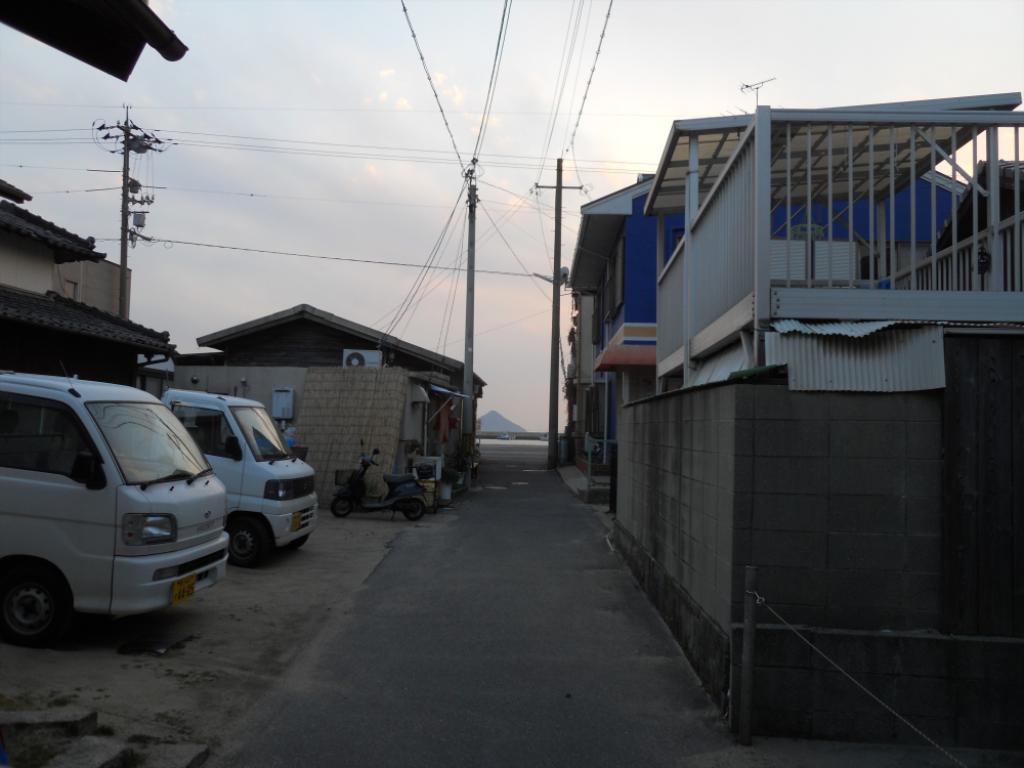Describe this image in one or two sentences. In this image there are buildings and we can see vehicles. There is a road and we can see poles. At the top there are wires and sky. 